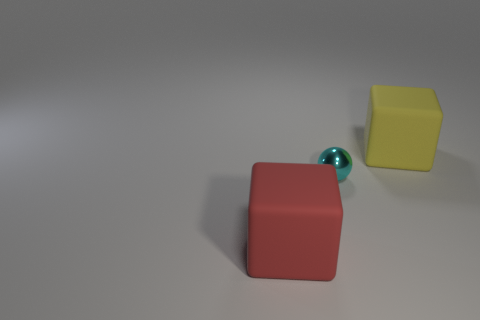How many red matte things have the same size as the red cube?
Provide a short and direct response. 0. What is the material of the tiny object?
Keep it short and to the point. Metal. There is a large yellow thing; are there any cyan spheres on the right side of it?
Your answer should be compact. No. What size is the yellow object that is made of the same material as the red thing?
Provide a short and direct response. Large. How many balls have the same color as the tiny metal thing?
Offer a terse response. 0. Are there fewer red rubber blocks that are behind the tiny metallic sphere than large yellow matte cubes behind the large yellow rubber object?
Offer a very short reply. No. There is a matte cube that is right of the red rubber thing; what size is it?
Offer a very short reply. Large. Is there a large object made of the same material as the red block?
Ensure brevity in your answer.  Yes. Do the big yellow cube and the cyan sphere have the same material?
Offer a very short reply. No. What color is the rubber cube that is the same size as the yellow object?
Keep it short and to the point. Red. 